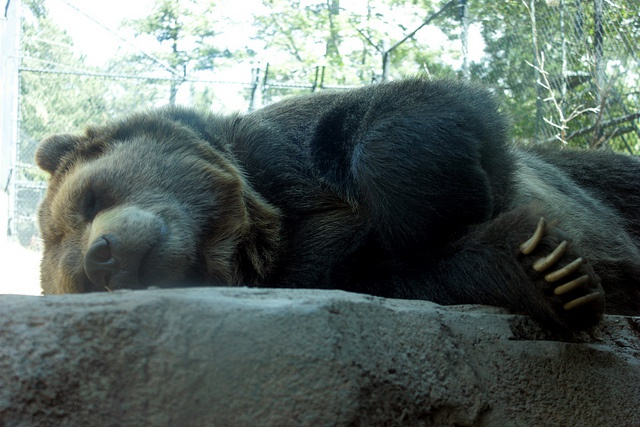Describe the objects in this image and their specific colors. I can see a bear in white, black, gray, purple, and darkgray tones in this image. 